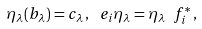<formula> <loc_0><loc_0><loc_500><loc_500>\eta _ { \lambda } ( b _ { \lambda } ) = c _ { \lambda } \, , \, \ e _ { i } \eta _ { \lambda } = \eta _ { \lambda } \ f _ { i } ^ { * } \, ,</formula> 